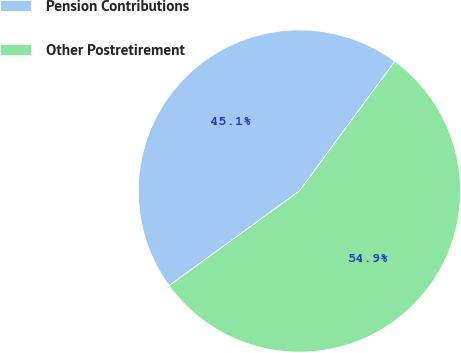Convert chart to OTSL. <chart><loc_0><loc_0><loc_500><loc_500><pie_chart><fcel>Pension Contributions<fcel>Other Postretirement<nl><fcel>45.1%<fcel>54.9%<nl></chart> 